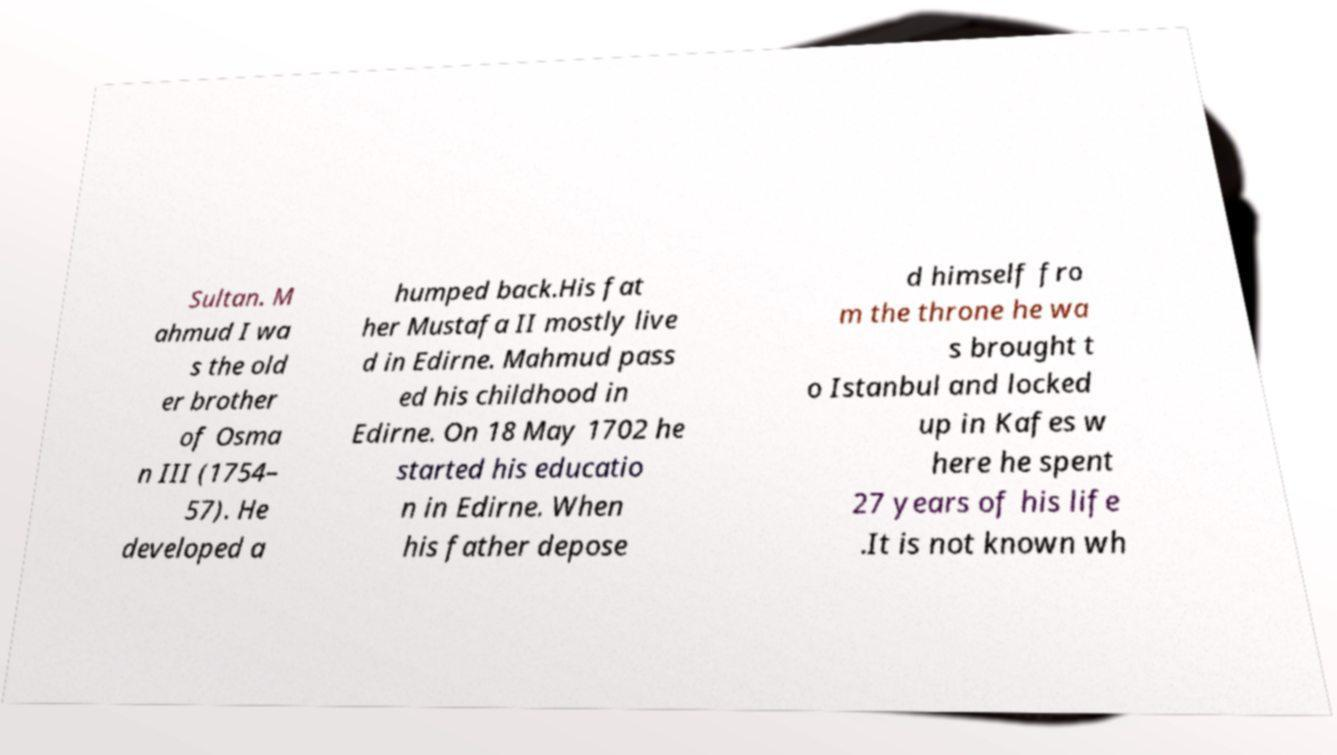Can you accurately transcribe the text from the provided image for me? Sultan. M ahmud I wa s the old er brother of Osma n III (1754– 57). He developed a humped back.His fat her Mustafa II mostly live d in Edirne. Mahmud pass ed his childhood in Edirne. On 18 May 1702 he started his educatio n in Edirne. When his father depose d himself fro m the throne he wa s brought t o Istanbul and locked up in Kafes w here he spent 27 years of his life .It is not known wh 